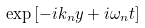Convert formula to latex. <formula><loc_0><loc_0><loc_500><loc_500>\exp \left [ - i k _ { n } y + i \omega _ { n } t \right ]</formula> 